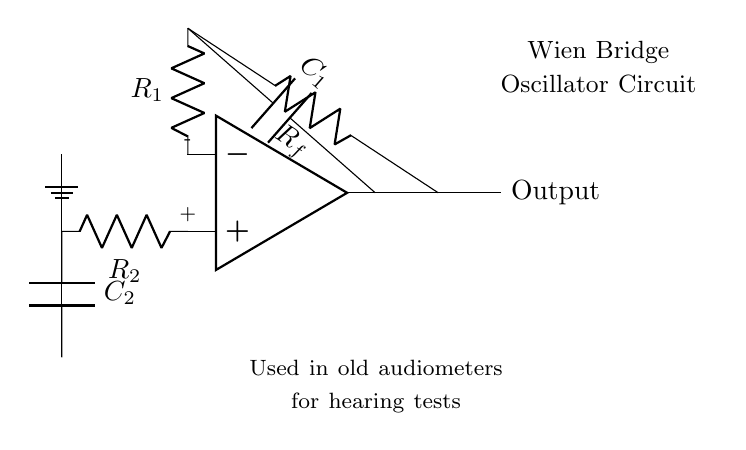What type of oscillator is shown here? The circuit is labeled as a Wien Bridge Oscillator, which is indicated in the diagram. The label specifies its function clearly.
Answer: Wien Bridge Oscillator What are the values assigned to the components? The circuit includes resistors labeled as R1, R2, and a feedback resistor labeled as Rf, as well as capacitors C1 and C2. These labels denote their roles without specific numerical values provided in the diagram.
Answer: R1, R2, Rf, C1, C2 Which component is used for feedback? The circuit shows a resistor labeled Rf connecting the output to one of the input points of the op-amp, indicating that it’s used for feedback in the oscillator operation.
Answer: Rf In which devices was this circuit used? The description below the circuit explicitly states that it was "Used in old audiometers for hearing tests." This historical context provides insight into its application in medical examinations.
Answer: Old audiometers What is the main function of this circuit? The label in the circuit indicates its primary function as an oscillator, and considering its application in audiometers, it is used for generating audio signals. This is part of testing hearing abilities.
Answer: Generating audio signals How does this circuit maintain stability in output frequency? The Wien Bridge Oscillator achieves frequency stability through its feedback network, which employs both resistors and capacitors. This combination ensures that the output frequency remains stable by balancing gain and phase shift.
Answer: Feedback network stability 